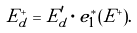Convert formula to latex. <formula><loc_0><loc_0><loc_500><loc_500>E ^ { + } _ { d } = E ^ { \prime } _ { d } \cdot e _ { 1 } ^ { * } ( E ^ { + } ) .</formula> 